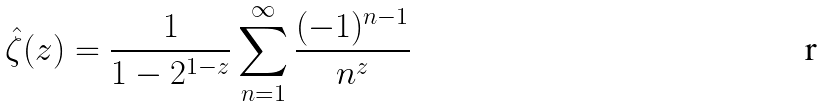Convert formula to latex. <formula><loc_0><loc_0><loc_500><loc_500>\hat { \zeta } ( z ) = \frac { 1 } { 1 - 2 ^ { 1 - z } } \sum _ { n = 1 } ^ { \infty } \frac { ( - 1 ) ^ { n - 1 } } { n ^ { z } }</formula> 